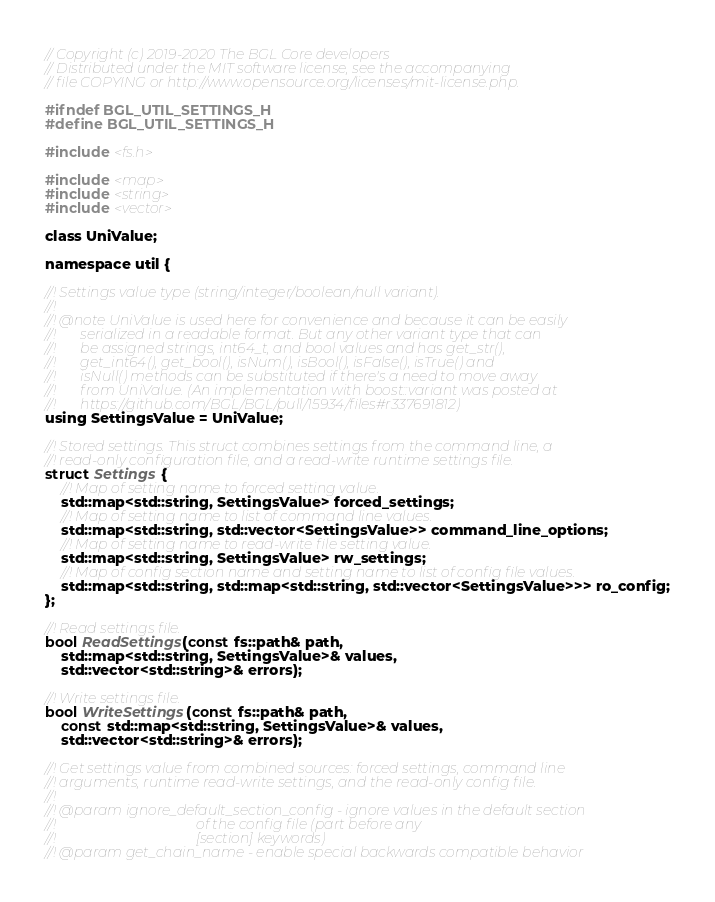<code> <loc_0><loc_0><loc_500><loc_500><_C_>// Copyright (c) 2019-2020 The BGL Core developers
// Distributed under the MIT software license, see the accompanying
// file COPYING or http://www.opensource.org/licenses/mit-license.php.

#ifndef BGL_UTIL_SETTINGS_H
#define BGL_UTIL_SETTINGS_H

#include <fs.h>

#include <map>
#include <string>
#include <vector>

class UniValue;

namespace util {

//! Settings value type (string/integer/boolean/null variant).
//!
//! @note UniValue is used here for convenience and because it can be easily
//!       serialized in a readable format. But any other variant type that can
//!       be assigned strings, int64_t, and bool values and has get_str(),
//!       get_int64(), get_bool(), isNum(), isBool(), isFalse(), isTrue() and
//!       isNull() methods can be substituted if there's a need to move away
//!       from UniValue. (An implementation with boost::variant was posted at
//!       https://github.com/BGL/BGL/pull/15934/files#r337691812)
using SettingsValue = UniValue;

//! Stored settings. This struct combines settings from the command line, a
//! read-only configuration file, and a read-write runtime settings file.
struct Settings {
    //! Map of setting name to forced setting value.
    std::map<std::string, SettingsValue> forced_settings;
    //! Map of setting name to list of command line values.
    std::map<std::string, std::vector<SettingsValue>> command_line_options;
    //! Map of setting name to read-write file setting value.
    std::map<std::string, SettingsValue> rw_settings;
    //! Map of config section name and setting name to list of config file values.
    std::map<std::string, std::map<std::string, std::vector<SettingsValue>>> ro_config;
};

//! Read settings file.
bool ReadSettings(const fs::path& path,
    std::map<std::string, SettingsValue>& values,
    std::vector<std::string>& errors);

//! Write settings file.
bool WriteSettings(const fs::path& path,
    const std::map<std::string, SettingsValue>& values,
    std::vector<std::string>& errors);

//! Get settings value from combined sources: forced settings, command line
//! arguments, runtime read-write settings, and the read-only config file.
//!
//! @param ignore_default_section_config - ignore values in the default section
//!                                        of the config file (part before any
//!                                        [section] keywords)
//! @param get_chain_name - enable special backwards compatible behavior</code> 